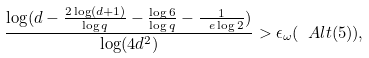Convert formula to latex. <formula><loc_0><loc_0><loc_500><loc_500>\frac { \log ( d - \frac { 2 \log ( d + 1 ) } { \log { q } } - \frac { \log { 6 } } { \log { q } } - \frac { 1 } { \ e \log { 2 } } ) } { \log ( 4 d ^ { 2 } ) } > \epsilon _ { \omega } ( \ A l t ( 5 ) ) ,</formula> 